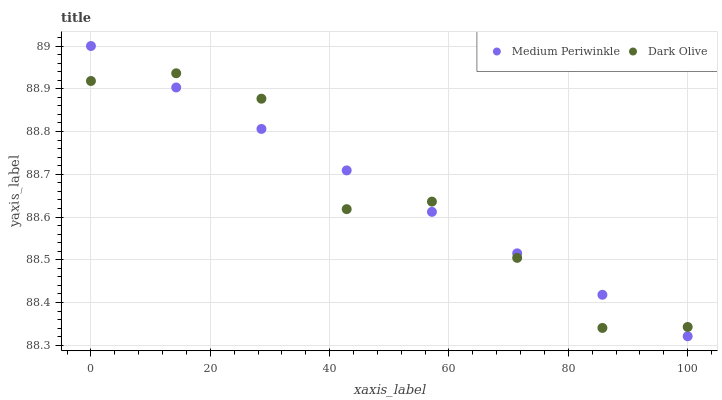Does Dark Olive have the minimum area under the curve?
Answer yes or no. Yes. Does Medium Periwinkle have the maximum area under the curve?
Answer yes or no. Yes. Does Medium Periwinkle have the minimum area under the curve?
Answer yes or no. No. Is Medium Periwinkle the smoothest?
Answer yes or no. Yes. Is Dark Olive the roughest?
Answer yes or no. Yes. Is Medium Periwinkle the roughest?
Answer yes or no. No. Does Medium Periwinkle have the lowest value?
Answer yes or no. Yes. Does Medium Periwinkle have the highest value?
Answer yes or no. Yes. Does Dark Olive intersect Medium Periwinkle?
Answer yes or no. Yes. Is Dark Olive less than Medium Periwinkle?
Answer yes or no. No. Is Dark Olive greater than Medium Periwinkle?
Answer yes or no. No. 